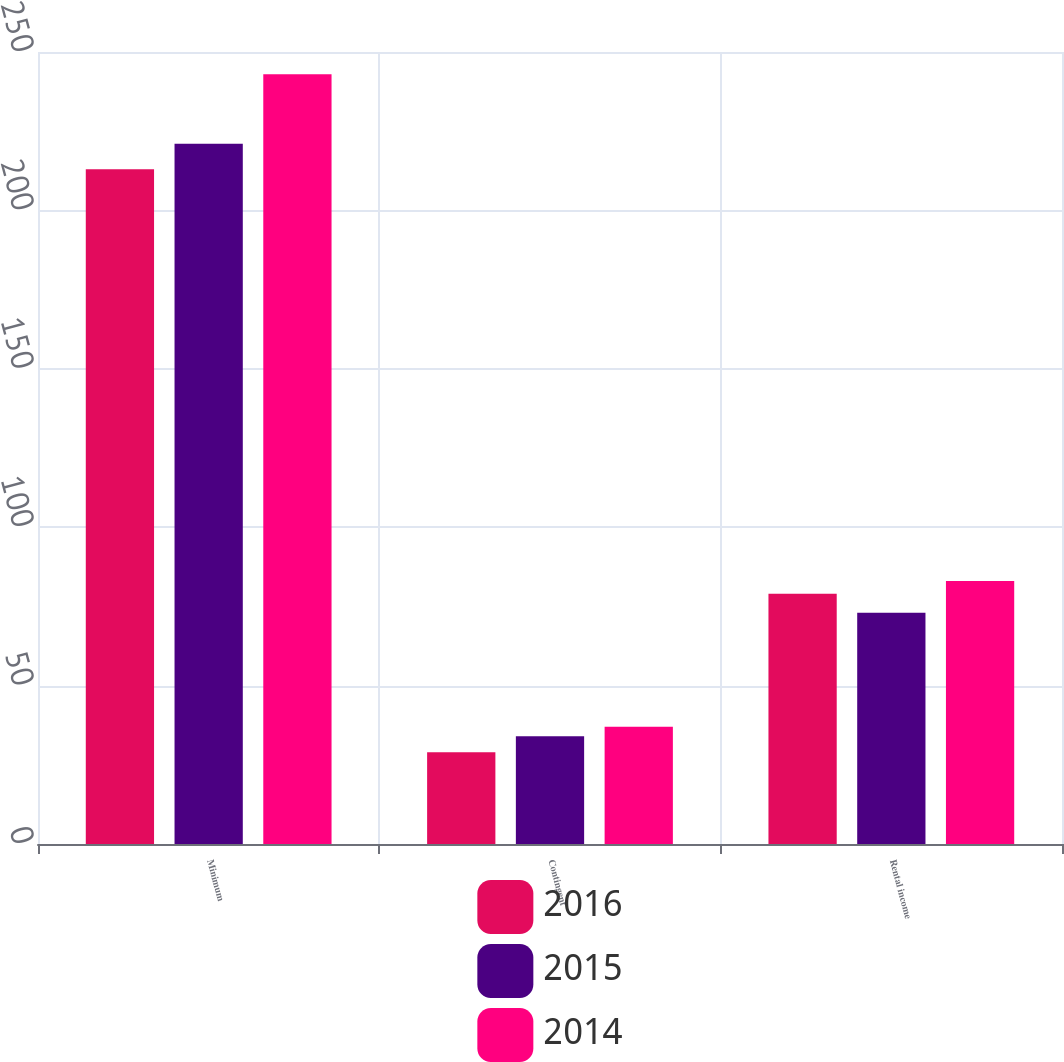Convert chart to OTSL. <chart><loc_0><loc_0><loc_500><loc_500><stacked_bar_chart><ecel><fcel>Minimum<fcel>Contingent<fcel>Rental income<nl><fcel>2016<fcel>213<fcel>29<fcel>79<nl><fcel>2015<fcel>221<fcel>34<fcel>73<nl><fcel>2014<fcel>243<fcel>37<fcel>83<nl></chart> 